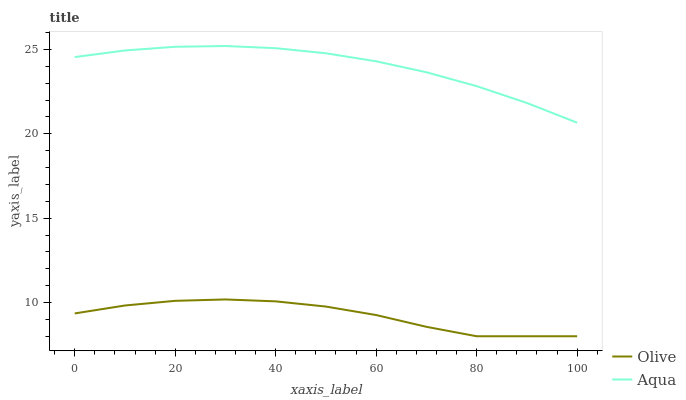Does Olive have the minimum area under the curve?
Answer yes or no. Yes. Does Aqua have the maximum area under the curve?
Answer yes or no. Yes. Does Aqua have the minimum area under the curve?
Answer yes or no. No. Is Aqua the smoothest?
Answer yes or no. Yes. Is Olive the roughest?
Answer yes or no. Yes. Is Aqua the roughest?
Answer yes or no. No. Does Olive have the lowest value?
Answer yes or no. Yes. Does Aqua have the lowest value?
Answer yes or no. No. Does Aqua have the highest value?
Answer yes or no. Yes. Is Olive less than Aqua?
Answer yes or no. Yes. Is Aqua greater than Olive?
Answer yes or no. Yes. Does Olive intersect Aqua?
Answer yes or no. No. 